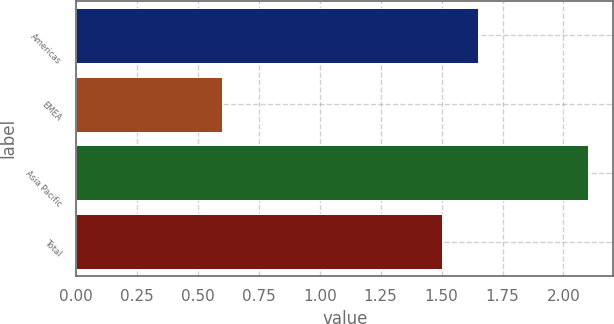<chart> <loc_0><loc_0><loc_500><loc_500><bar_chart><fcel>Americas<fcel>EMEA<fcel>Asia Pacific<fcel>Total<nl><fcel>1.65<fcel>0.6<fcel>2.1<fcel>1.5<nl></chart> 